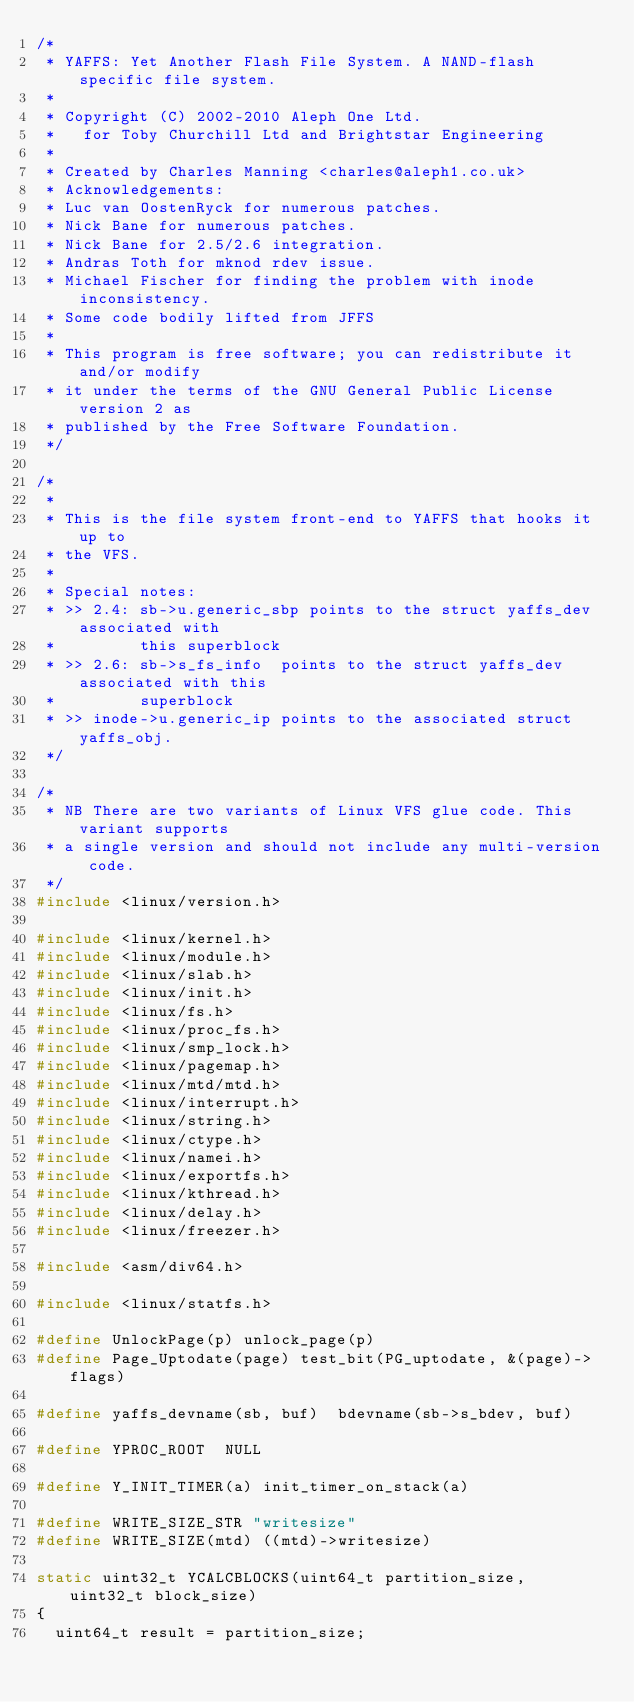<code> <loc_0><loc_0><loc_500><loc_500><_C_>/*
 * YAFFS: Yet Another Flash File System. A NAND-flash specific file system.
 *
 * Copyright (C) 2002-2010 Aleph One Ltd.
 *   for Toby Churchill Ltd and Brightstar Engineering
 *
 * Created by Charles Manning <charles@aleph1.co.uk>
 * Acknowledgements:
 * Luc van OostenRyck for numerous patches.
 * Nick Bane for numerous patches.
 * Nick Bane for 2.5/2.6 integration.
 * Andras Toth for mknod rdev issue.
 * Michael Fischer for finding the problem with inode inconsistency.
 * Some code bodily lifted from JFFS
 *
 * This program is free software; you can redistribute it and/or modify
 * it under the terms of the GNU General Public License version 2 as
 * published by the Free Software Foundation.
 */

/*
 *
 * This is the file system front-end to YAFFS that hooks it up to
 * the VFS.
 *
 * Special notes:
 * >> 2.4: sb->u.generic_sbp points to the struct yaffs_dev associated with
 *         this superblock
 * >> 2.6: sb->s_fs_info  points to the struct yaffs_dev associated with this
 *         superblock
 * >> inode->u.generic_ip points to the associated struct yaffs_obj.
 */

/*
 * NB There are two variants of Linux VFS glue code. This variant supports
 * a single version and should not include any multi-version code.
 */
#include <linux/version.h>

#include <linux/kernel.h>
#include <linux/module.h>
#include <linux/slab.h>
#include <linux/init.h>
#include <linux/fs.h>
#include <linux/proc_fs.h>
#include <linux/smp_lock.h>
#include <linux/pagemap.h>
#include <linux/mtd/mtd.h>
#include <linux/interrupt.h>
#include <linux/string.h>
#include <linux/ctype.h>
#include <linux/namei.h>
#include <linux/exportfs.h>
#include <linux/kthread.h>
#include <linux/delay.h>
#include <linux/freezer.h>

#include <asm/div64.h>

#include <linux/statfs.h>

#define UnlockPage(p) unlock_page(p)
#define Page_Uptodate(page)	test_bit(PG_uptodate, &(page)->flags)

#define yaffs_devname(sb, buf)	bdevname(sb->s_bdev, buf)

#define YPROC_ROOT  NULL

#define Y_INIT_TIMER(a)	init_timer_on_stack(a)

#define WRITE_SIZE_STR "writesize"
#define WRITE_SIZE(mtd) ((mtd)->writesize)

static uint32_t YCALCBLOCKS(uint64_t partition_size, uint32_t block_size)
{
	uint64_t result = partition_size;</code> 